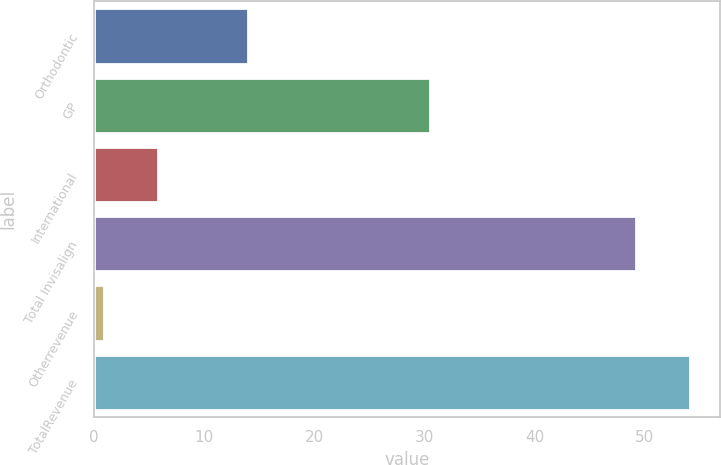Convert chart. <chart><loc_0><loc_0><loc_500><loc_500><bar_chart><fcel>Orthodontic<fcel>GP<fcel>International<fcel>Total Invisalign<fcel>Otherrevenue<fcel>TotalRevenue<nl><fcel>14<fcel>30.5<fcel>5.82<fcel>49.2<fcel>0.9<fcel>54.12<nl></chart> 